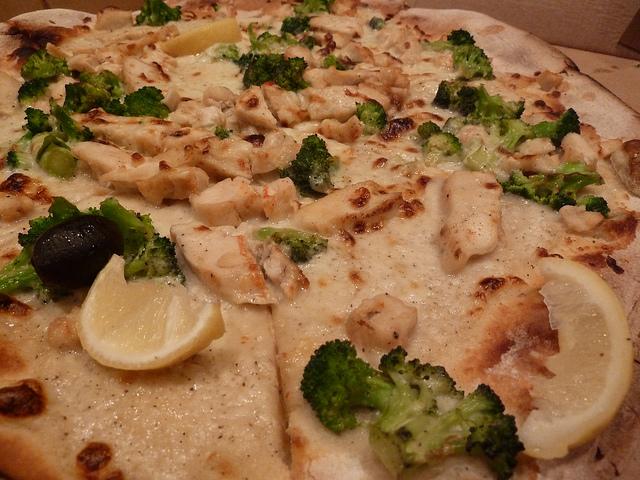Does this meal look suitable for a diner adhering to a vegetarian diet?
Be succinct. No. Is it a pizza?
Answer briefly. Yes. Which fruit is shown here?
Concise answer only. Lemon. 